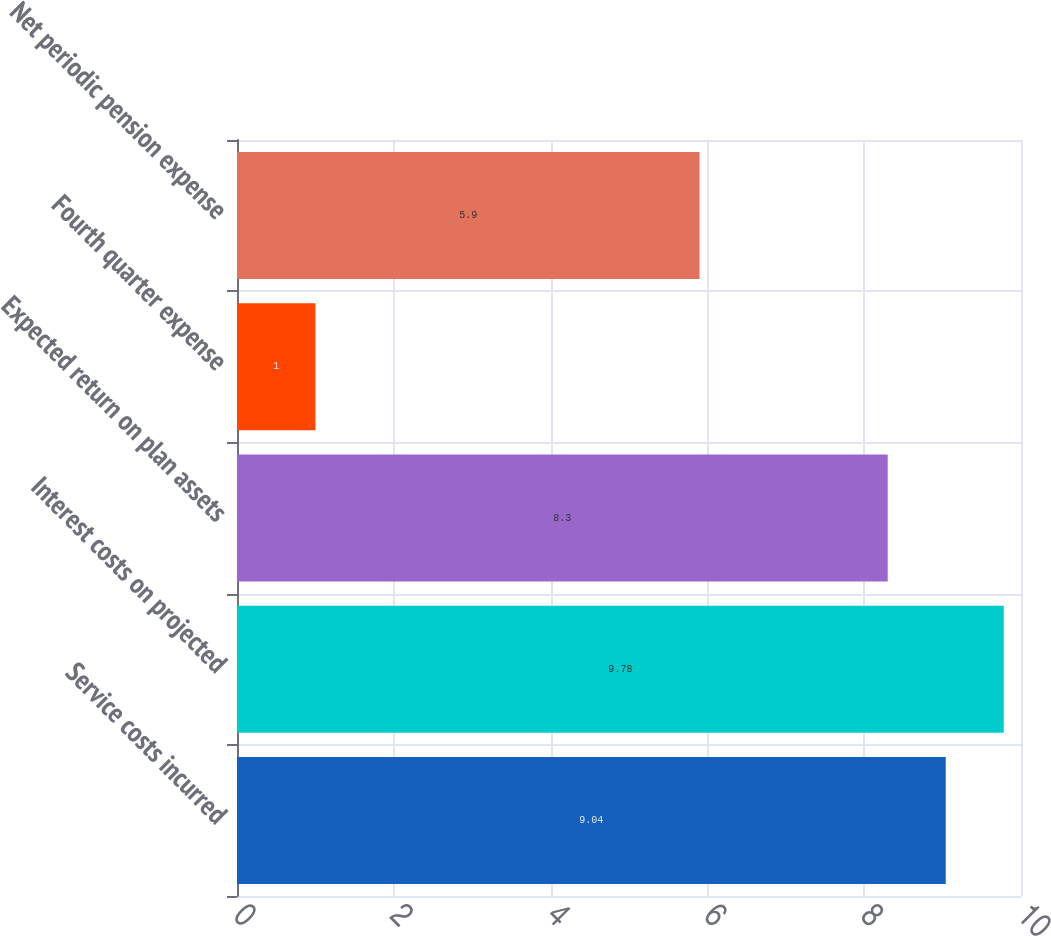<chart> <loc_0><loc_0><loc_500><loc_500><bar_chart><fcel>Service costs incurred<fcel>Interest costs on projected<fcel>Expected return on plan assets<fcel>Fourth quarter expense<fcel>Net periodic pension expense<nl><fcel>9.04<fcel>9.78<fcel>8.3<fcel>1<fcel>5.9<nl></chart> 